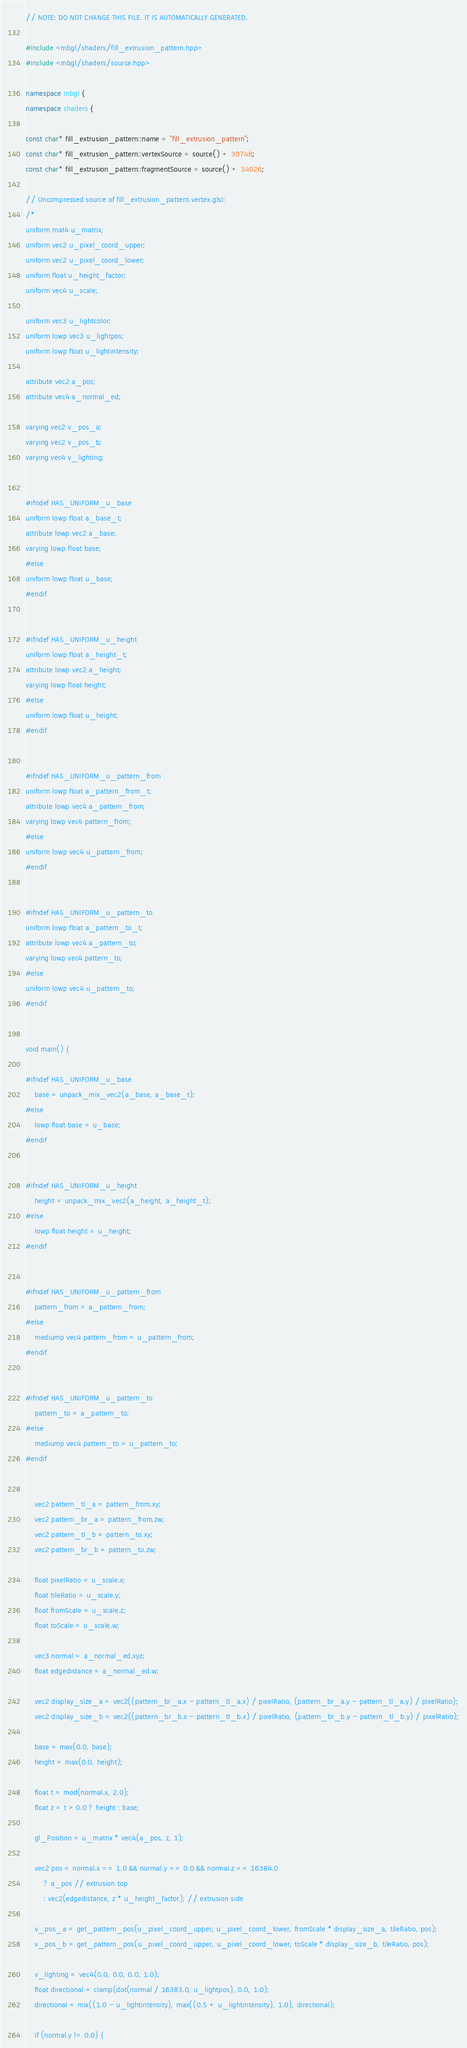Convert code to text. <code><loc_0><loc_0><loc_500><loc_500><_C++_>// NOTE: DO NOT CHANGE THIS FILE. IT IS AUTOMATICALLY GENERATED.

#include <mbgl/shaders/fill_extrusion_pattern.hpp>
#include <mbgl/shaders/source.hpp>

namespace mbgl {
namespace shaders {

const char* fill_extrusion_pattern::name = "fill_extrusion_pattern";
const char* fill_extrusion_pattern::vertexSource = source() + 30748;
const char* fill_extrusion_pattern::fragmentSource = source() + 34026;

// Uncompressed source of fill_extrusion_pattern.vertex.glsl:
/*
uniform mat4 u_matrix;
uniform vec2 u_pixel_coord_upper;
uniform vec2 u_pixel_coord_lower;
uniform float u_height_factor;
uniform vec4 u_scale;

uniform vec3 u_lightcolor;
uniform lowp vec3 u_lightpos;
uniform lowp float u_lightintensity;

attribute vec2 a_pos;
attribute vec4 a_normal_ed;

varying vec2 v_pos_a;
varying vec2 v_pos_b;
varying vec4 v_lighting;


#ifndef HAS_UNIFORM_u_base
uniform lowp float a_base_t;
attribute lowp vec2 a_base;
varying lowp float base;
#else
uniform lowp float u_base;
#endif


#ifndef HAS_UNIFORM_u_height
uniform lowp float a_height_t;
attribute lowp vec2 a_height;
varying lowp float height;
#else
uniform lowp float u_height;
#endif


#ifndef HAS_UNIFORM_u_pattern_from
uniform lowp float a_pattern_from_t;
attribute lowp vec4 a_pattern_from;
varying lowp vec4 pattern_from;
#else
uniform lowp vec4 u_pattern_from;
#endif


#ifndef HAS_UNIFORM_u_pattern_to
uniform lowp float a_pattern_to_t;
attribute lowp vec4 a_pattern_to;
varying lowp vec4 pattern_to;
#else
uniform lowp vec4 u_pattern_to;
#endif


void main() {
    
#ifndef HAS_UNIFORM_u_base
    base = unpack_mix_vec2(a_base, a_base_t);
#else
    lowp float base = u_base;
#endif

    
#ifndef HAS_UNIFORM_u_height
    height = unpack_mix_vec2(a_height, a_height_t);
#else
    lowp float height = u_height;
#endif

    
#ifndef HAS_UNIFORM_u_pattern_from
    pattern_from = a_pattern_from;
#else
    mediump vec4 pattern_from = u_pattern_from;
#endif

    
#ifndef HAS_UNIFORM_u_pattern_to
    pattern_to = a_pattern_to;
#else
    mediump vec4 pattern_to = u_pattern_to;
#endif


    vec2 pattern_tl_a = pattern_from.xy;
    vec2 pattern_br_a = pattern_from.zw;
    vec2 pattern_tl_b = pattern_to.xy;
    vec2 pattern_br_b = pattern_to.zw;

    float pixelRatio = u_scale.x;
    float tileRatio = u_scale.y;
    float fromScale = u_scale.z;
    float toScale = u_scale.w;

    vec3 normal = a_normal_ed.xyz;
    float edgedistance = a_normal_ed.w;

    vec2 display_size_a = vec2((pattern_br_a.x - pattern_tl_a.x) / pixelRatio, (pattern_br_a.y - pattern_tl_a.y) / pixelRatio);
    vec2 display_size_b = vec2((pattern_br_b.x - pattern_tl_b.x) / pixelRatio, (pattern_br_b.y - pattern_tl_b.y) / pixelRatio);

    base = max(0.0, base);
    height = max(0.0, height);

    float t = mod(normal.x, 2.0);
    float z = t > 0.0 ? height : base;

    gl_Position = u_matrix * vec4(a_pos, z, 1);

    vec2 pos = normal.x == 1.0 && normal.y == 0.0 && normal.z == 16384.0
        ? a_pos // extrusion top
        : vec2(edgedistance, z * u_height_factor); // extrusion side

    v_pos_a = get_pattern_pos(u_pixel_coord_upper, u_pixel_coord_lower, fromScale * display_size_a, tileRatio, pos);
    v_pos_b = get_pattern_pos(u_pixel_coord_upper, u_pixel_coord_lower, toScale * display_size_b, tileRatio, pos);

    v_lighting = vec4(0.0, 0.0, 0.0, 1.0);
    float directional = clamp(dot(normal / 16383.0, u_lightpos), 0.0, 1.0);
    directional = mix((1.0 - u_lightintensity), max((0.5 + u_lightintensity), 1.0), directional);

    if (normal.y != 0.0) {</code> 